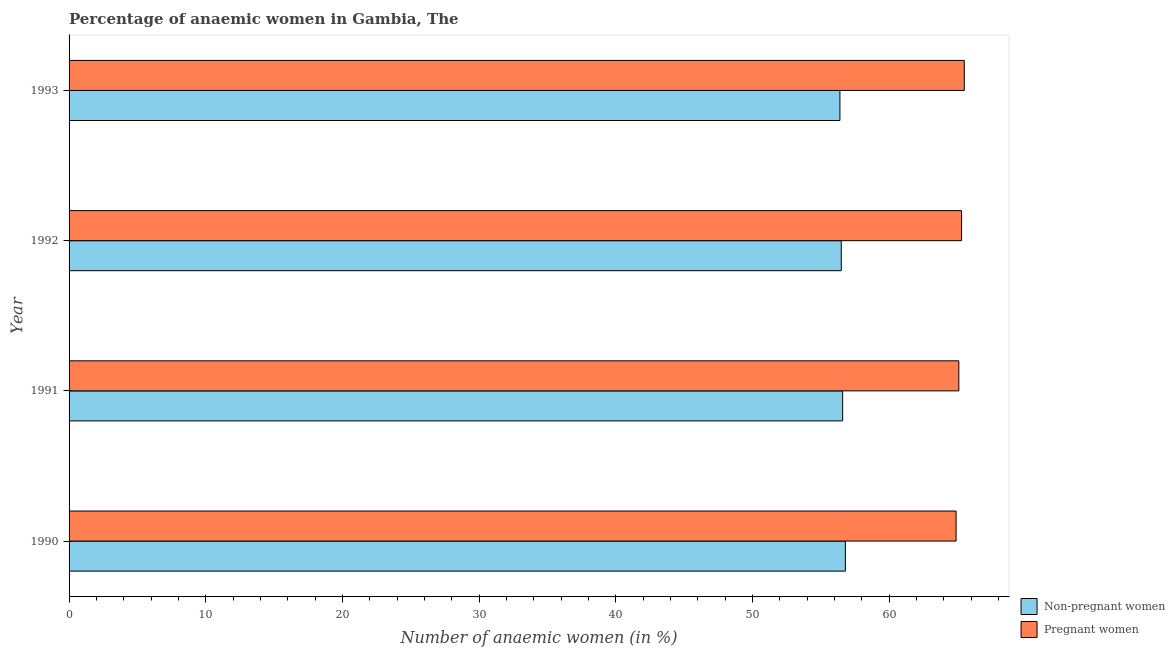How many different coloured bars are there?
Offer a very short reply. 2. How many groups of bars are there?
Your answer should be very brief. 4. How many bars are there on the 4th tick from the top?
Make the answer very short. 2. What is the label of the 3rd group of bars from the top?
Your answer should be compact. 1991. What is the percentage of pregnant anaemic women in 1993?
Offer a terse response. 65.5. Across all years, what is the maximum percentage of non-pregnant anaemic women?
Your response must be concise. 56.8. Across all years, what is the minimum percentage of non-pregnant anaemic women?
Offer a very short reply. 56.4. What is the total percentage of pregnant anaemic women in the graph?
Ensure brevity in your answer.  260.8. What is the difference between the percentage of pregnant anaemic women in 1993 and the percentage of non-pregnant anaemic women in 1991?
Give a very brief answer. 8.9. What is the average percentage of pregnant anaemic women per year?
Make the answer very short. 65.2. Is the percentage of pregnant anaemic women in 1991 less than that in 1993?
Offer a terse response. Yes. What is the difference between the highest and the second highest percentage of non-pregnant anaemic women?
Provide a short and direct response. 0.2. What is the difference between the highest and the lowest percentage of non-pregnant anaemic women?
Provide a succinct answer. 0.4. What does the 1st bar from the top in 1991 represents?
Your answer should be very brief. Pregnant women. What does the 1st bar from the bottom in 1993 represents?
Ensure brevity in your answer.  Non-pregnant women. What is the difference between two consecutive major ticks on the X-axis?
Give a very brief answer. 10. Are the values on the major ticks of X-axis written in scientific E-notation?
Give a very brief answer. No. Does the graph contain any zero values?
Give a very brief answer. No. How many legend labels are there?
Ensure brevity in your answer.  2. What is the title of the graph?
Your answer should be very brief. Percentage of anaemic women in Gambia, The. Does "Adolescent fertility rate" appear as one of the legend labels in the graph?
Provide a succinct answer. No. What is the label or title of the X-axis?
Provide a short and direct response. Number of anaemic women (in %). What is the Number of anaemic women (in %) in Non-pregnant women in 1990?
Your answer should be very brief. 56.8. What is the Number of anaemic women (in %) of Pregnant women in 1990?
Your answer should be very brief. 64.9. What is the Number of anaemic women (in %) of Non-pregnant women in 1991?
Ensure brevity in your answer.  56.6. What is the Number of anaemic women (in %) in Pregnant women in 1991?
Your answer should be very brief. 65.1. What is the Number of anaemic women (in %) in Non-pregnant women in 1992?
Ensure brevity in your answer.  56.5. What is the Number of anaemic women (in %) in Pregnant women in 1992?
Offer a very short reply. 65.3. What is the Number of anaemic women (in %) of Non-pregnant women in 1993?
Provide a succinct answer. 56.4. What is the Number of anaemic women (in %) in Pregnant women in 1993?
Your answer should be compact. 65.5. Across all years, what is the maximum Number of anaemic women (in %) in Non-pregnant women?
Give a very brief answer. 56.8. Across all years, what is the maximum Number of anaemic women (in %) of Pregnant women?
Provide a succinct answer. 65.5. Across all years, what is the minimum Number of anaemic women (in %) in Non-pregnant women?
Give a very brief answer. 56.4. Across all years, what is the minimum Number of anaemic women (in %) of Pregnant women?
Your response must be concise. 64.9. What is the total Number of anaemic women (in %) in Non-pregnant women in the graph?
Keep it short and to the point. 226.3. What is the total Number of anaemic women (in %) of Pregnant women in the graph?
Offer a terse response. 260.8. What is the difference between the Number of anaemic women (in %) in Non-pregnant women in 1990 and that in 1991?
Your response must be concise. 0.2. What is the difference between the Number of anaemic women (in %) in Pregnant women in 1990 and that in 1991?
Your answer should be compact. -0.2. What is the difference between the Number of anaemic women (in %) in Non-pregnant women in 1990 and that in 1993?
Your answer should be very brief. 0.4. What is the difference between the Number of anaemic women (in %) in Non-pregnant women in 1991 and that in 1992?
Provide a short and direct response. 0.1. What is the difference between the Number of anaemic women (in %) in Pregnant women in 1991 and that in 1992?
Your response must be concise. -0.2. What is the difference between the Number of anaemic women (in %) of Non-pregnant women in 1992 and that in 1993?
Your answer should be very brief. 0.1. What is the difference between the Number of anaemic women (in %) of Non-pregnant women in 1990 and the Number of anaemic women (in %) of Pregnant women in 1992?
Your response must be concise. -8.5. What is the difference between the Number of anaemic women (in %) of Non-pregnant women in 1990 and the Number of anaemic women (in %) of Pregnant women in 1993?
Make the answer very short. -8.7. What is the difference between the Number of anaemic women (in %) in Non-pregnant women in 1991 and the Number of anaemic women (in %) in Pregnant women in 1992?
Your answer should be compact. -8.7. What is the difference between the Number of anaemic women (in %) of Non-pregnant women in 1992 and the Number of anaemic women (in %) of Pregnant women in 1993?
Your response must be concise. -9. What is the average Number of anaemic women (in %) of Non-pregnant women per year?
Provide a succinct answer. 56.58. What is the average Number of anaemic women (in %) in Pregnant women per year?
Offer a terse response. 65.2. In the year 1991, what is the difference between the Number of anaemic women (in %) of Non-pregnant women and Number of anaemic women (in %) of Pregnant women?
Provide a short and direct response. -8.5. In the year 1993, what is the difference between the Number of anaemic women (in %) of Non-pregnant women and Number of anaemic women (in %) of Pregnant women?
Provide a succinct answer. -9.1. What is the ratio of the Number of anaemic women (in %) of Pregnant women in 1990 to that in 1992?
Keep it short and to the point. 0.99. What is the ratio of the Number of anaemic women (in %) of Non-pregnant women in 1990 to that in 1993?
Offer a terse response. 1.01. What is the ratio of the Number of anaemic women (in %) of Pregnant women in 1990 to that in 1993?
Offer a terse response. 0.99. What is the ratio of the Number of anaemic women (in %) in Pregnant women in 1991 to that in 1992?
Your answer should be compact. 1. What is the ratio of the Number of anaemic women (in %) in Pregnant women in 1991 to that in 1993?
Provide a succinct answer. 0.99. What is the ratio of the Number of anaemic women (in %) of Non-pregnant women in 1992 to that in 1993?
Make the answer very short. 1. What is the difference between the highest and the second highest Number of anaemic women (in %) in Pregnant women?
Your answer should be very brief. 0.2. 